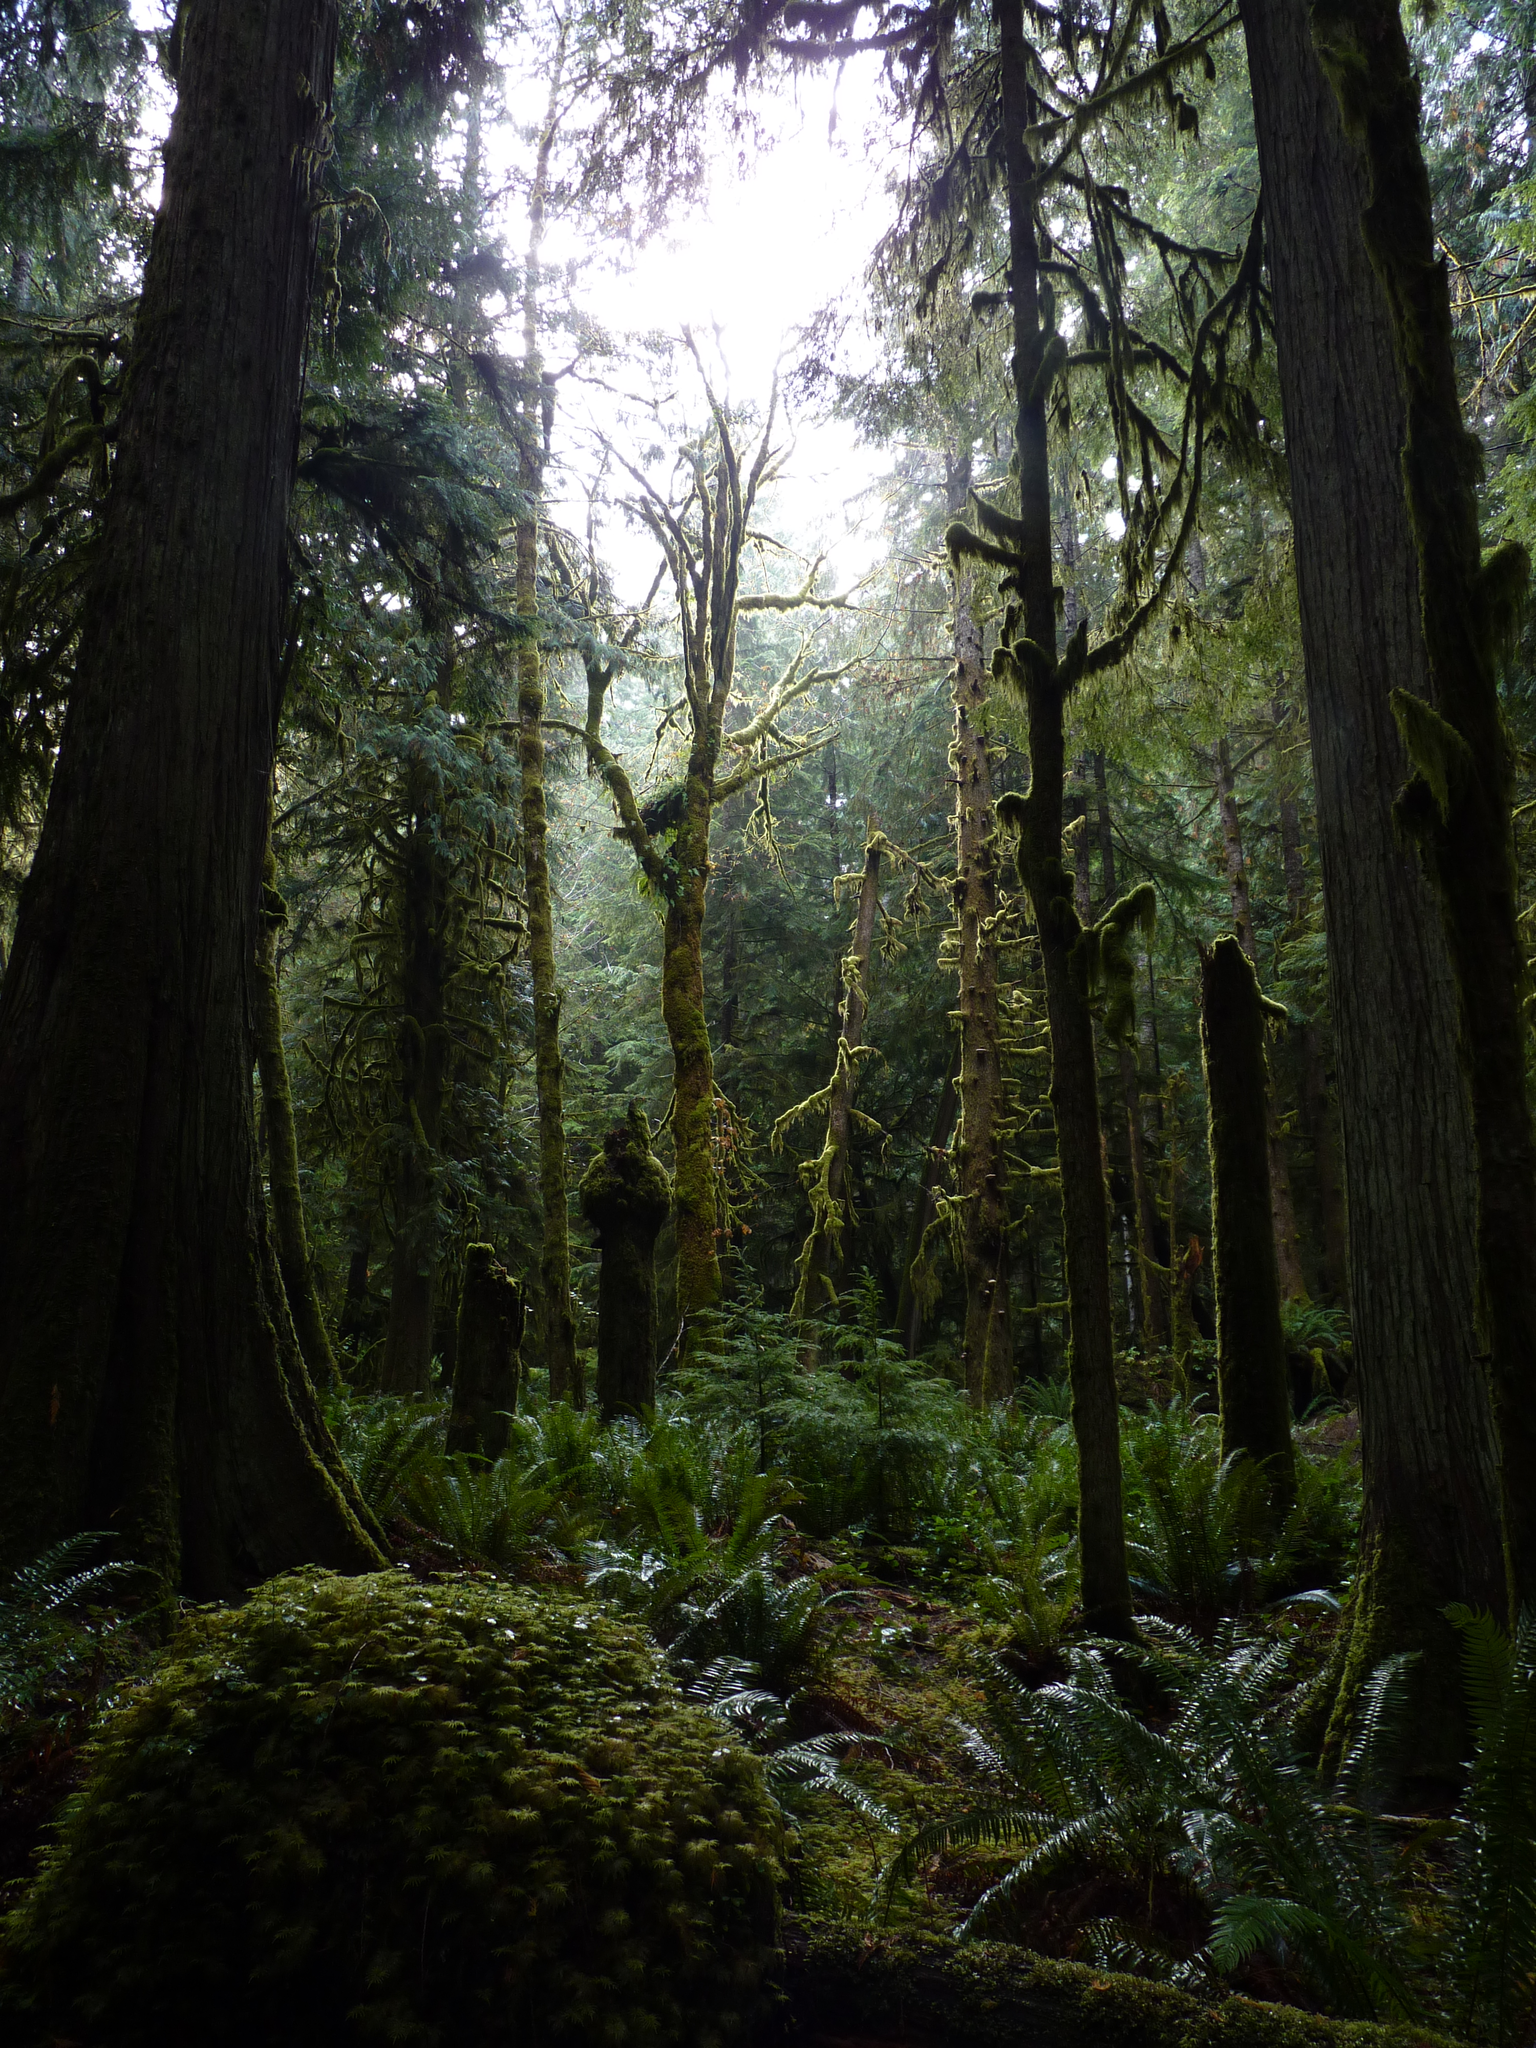Describe this image in one or two sentences. There are trees and plants on the ground. In the background, there is sky. 